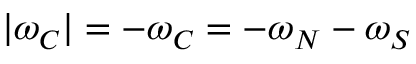<formula> <loc_0><loc_0><loc_500><loc_500>| \omega _ { C } | = - \omega _ { C } = - \omega _ { N } - \omega _ { S }</formula> 